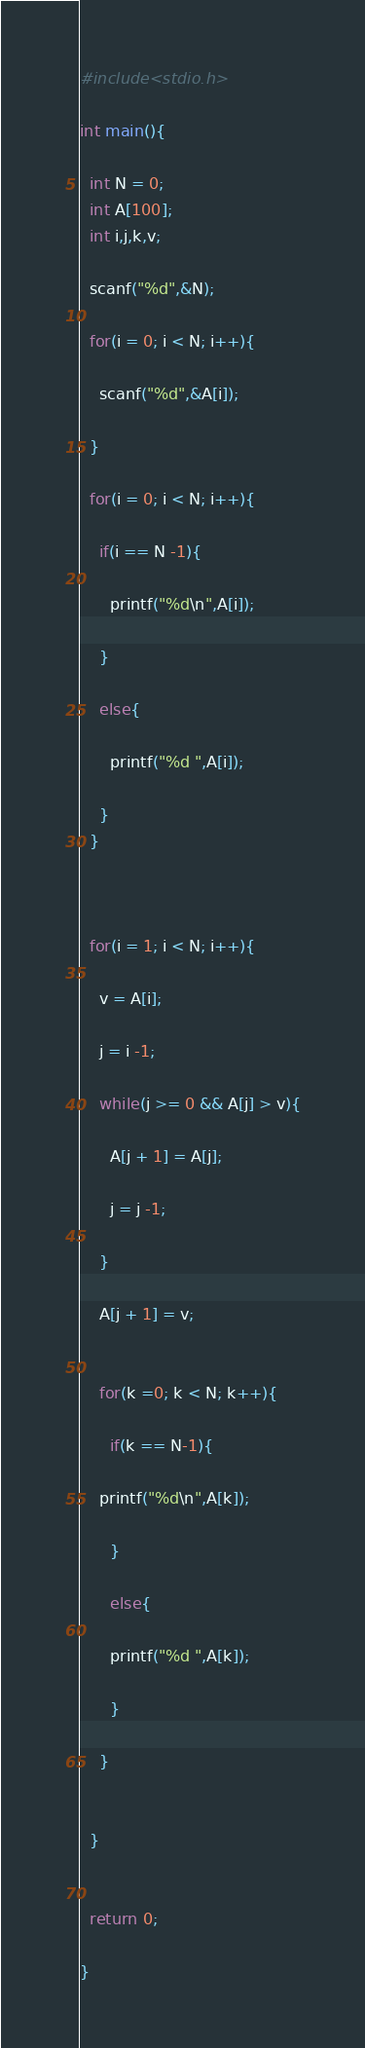Convert code to text. <code><loc_0><loc_0><loc_500><loc_500><_C_>#include<stdio.h>

int main(){

  int N = 0;
  int A[100];
  int i,j,k,v;

  scanf("%d",&N);

  for(i = 0; i < N; i++){

    scanf("%d",&A[i]);

  }

  for(i = 0; i < N; i++){

    if(i == N -1){

      printf("%d\n",A[i]);

    }

    else{

      printf("%d ",A[i]);

    }
  }



  for(i = 1; i < N; i++){

    v = A[i];

    j = i -1;

    while(j >= 0 && A[j] > v){

      A[j + 1] = A[j];

      j = j -1;

    }

    A[j + 1] = v;

    
    for(k =0; k < N; k++){

      if(k == N-1){

	printf("%d\n",A[k]);

      }

      else{
      
      printf("%d ",A[k]);

      }
    
    }


  }


  return 0;

}</code> 